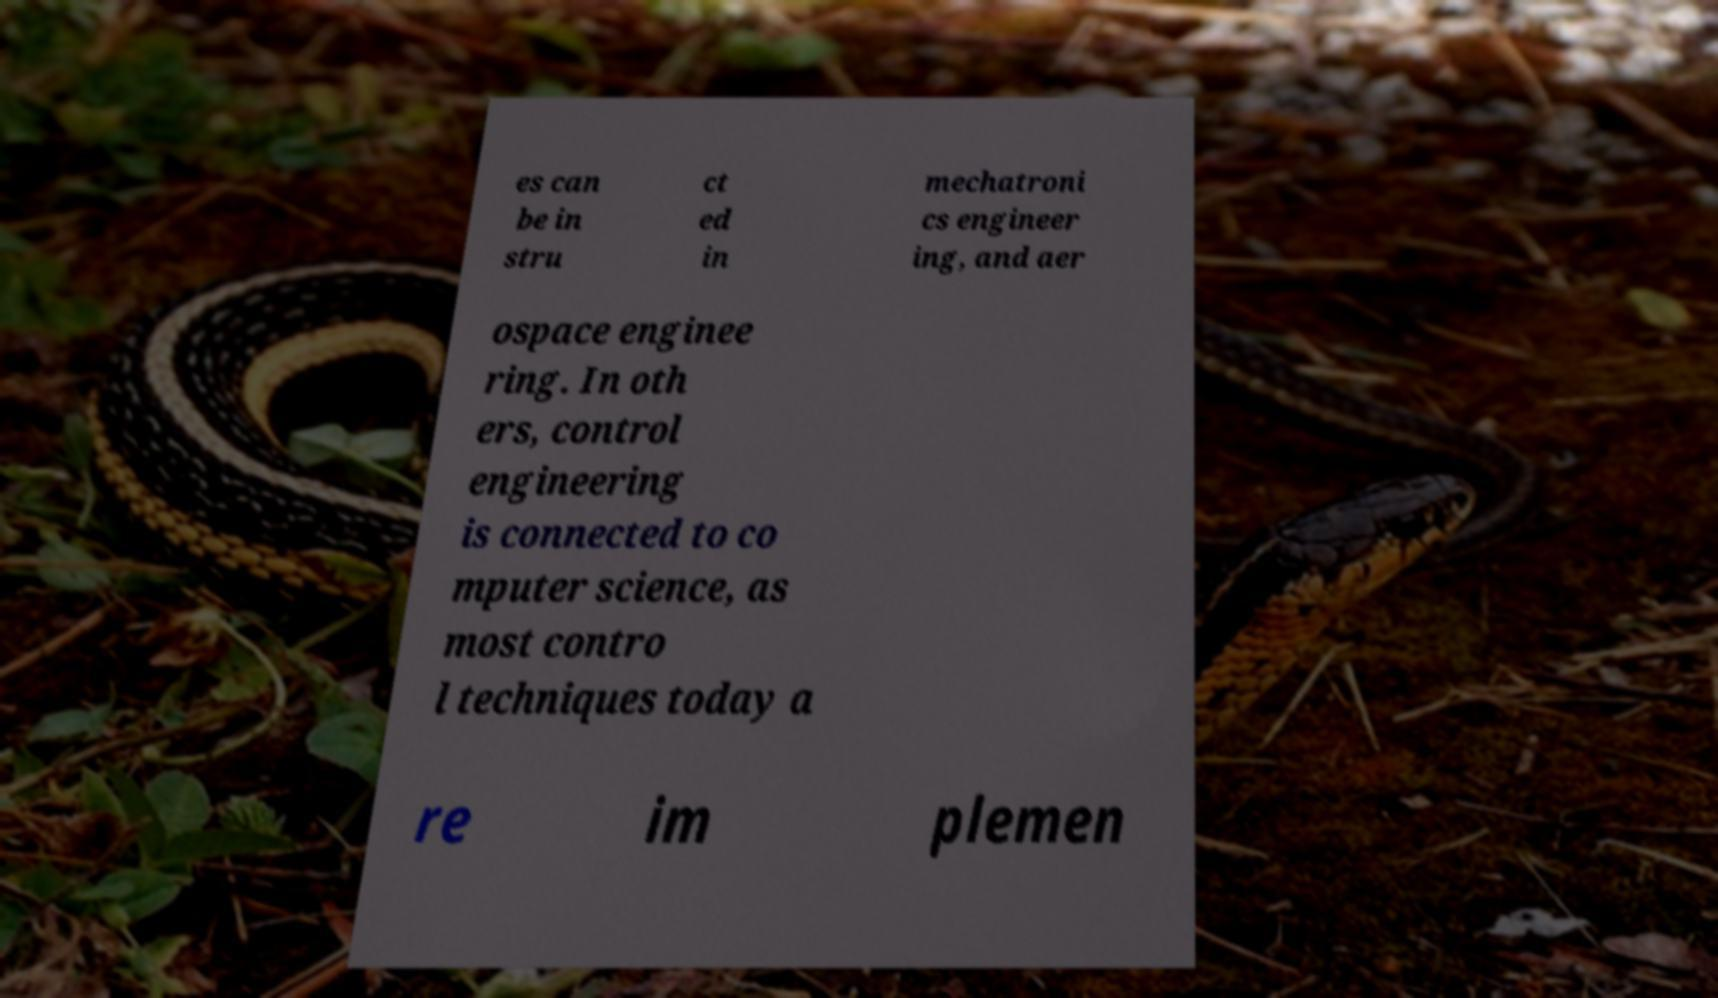I need the written content from this picture converted into text. Can you do that? es can be in stru ct ed in mechatroni cs engineer ing, and aer ospace enginee ring. In oth ers, control engineering is connected to co mputer science, as most contro l techniques today a re im plemen 